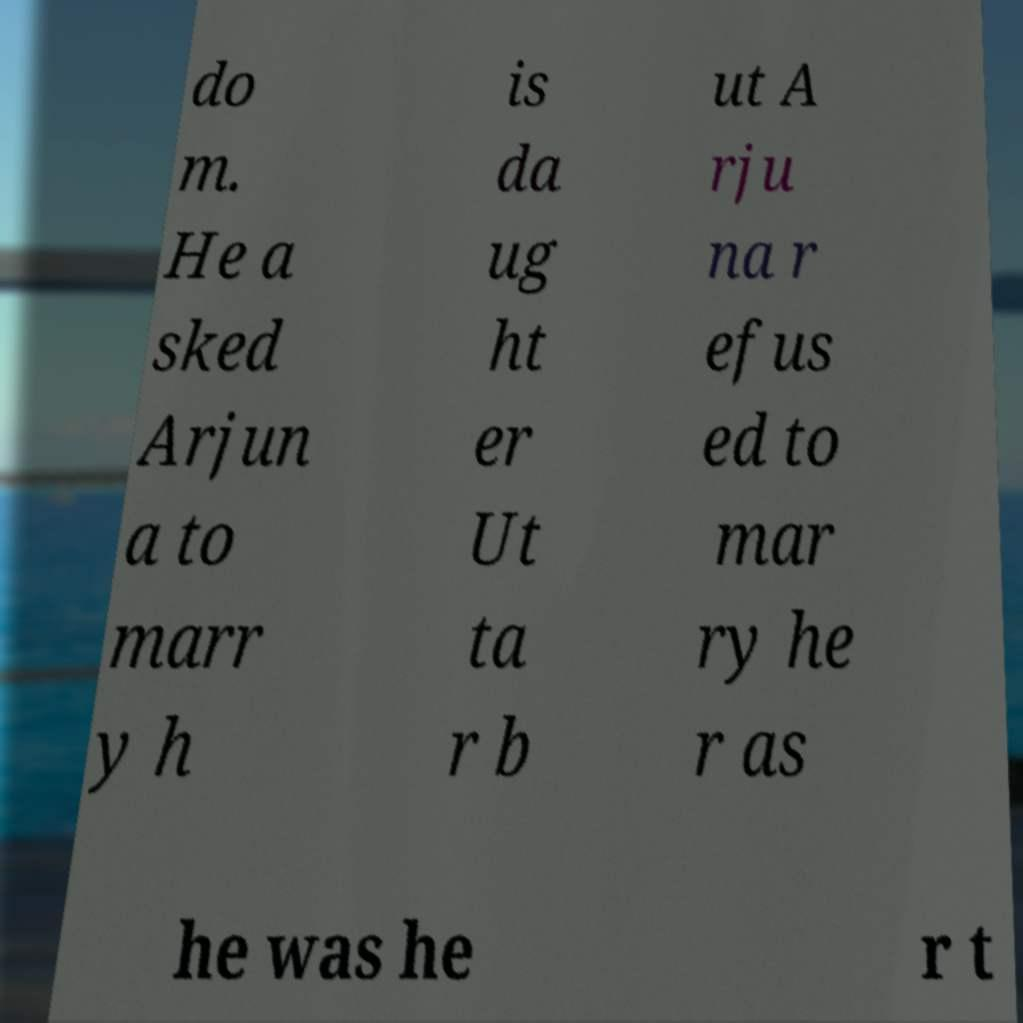Can you read and provide the text displayed in the image?This photo seems to have some interesting text. Can you extract and type it out for me? do m. He a sked Arjun a to marr y h is da ug ht er Ut ta r b ut A rju na r efus ed to mar ry he r as he was he r t 